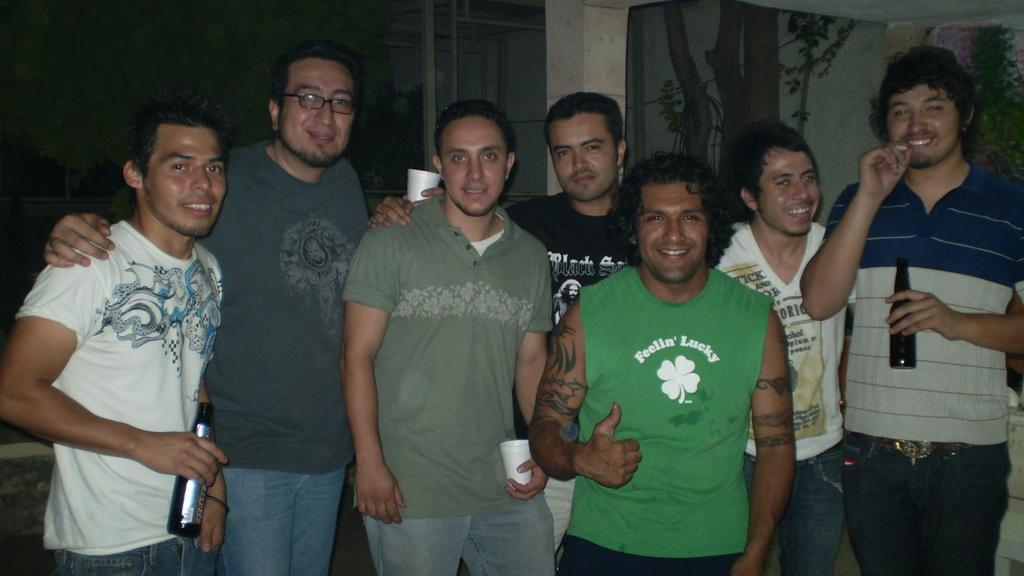What is the main subject of the image? The main subject of the image is a group of men. What are the men doing in the image? The men are standing and smiling in the image. What are the men holding in their hands? Some of the men are holding beer bottles, while others are holding glasses. Can you see any visible veins on the men's hands in the image? There is no information about the men's hands or veins in the image, so it cannot be determined. What type of office furniture can be seen in the image? There is no office furniture present in the image; it features a group of men standing and holding beer bottles and glasses. 